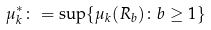<formula> <loc_0><loc_0><loc_500><loc_500>\mu _ { k } ^ { * } \colon = \sup \{ \mu _ { k } ( R _ { b } ) \colon b \geq 1 \}</formula> 